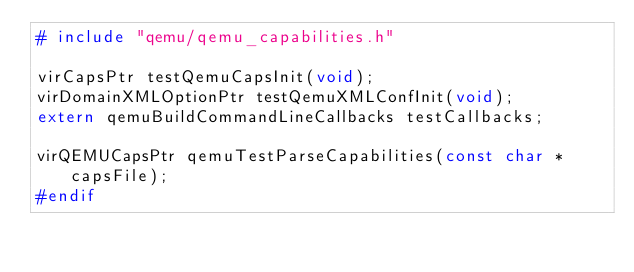Convert code to text. <code><loc_0><loc_0><loc_500><loc_500><_C_># include "qemu/qemu_capabilities.h"

virCapsPtr testQemuCapsInit(void);
virDomainXMLOptionPtr testQemuXMLConfInit(void);
extern qemuBuildCommandLineCallbacks testCallbacks;

virQEMUCapsPtr qemuTestParseCapabilities(const char *capsFile);
#endif
</code> 